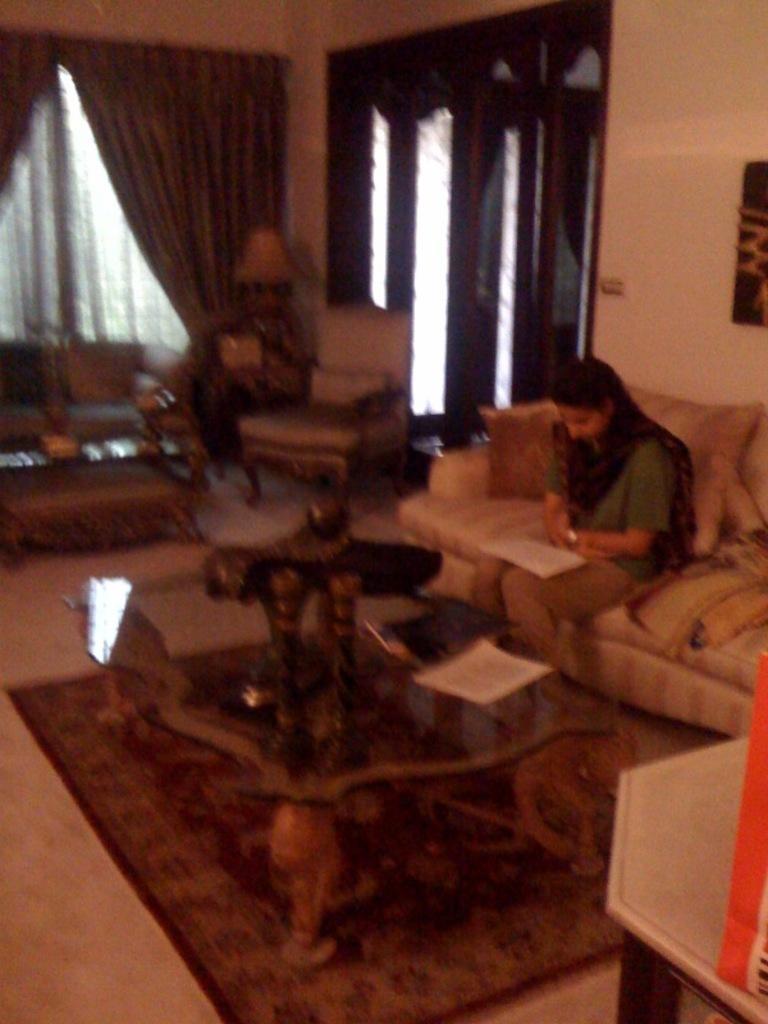Could you give a brief overview of what you see in this image? In the image there is a room with the furnished sofas, tables, frames, curtains and etc. In the bottom there is a mat covering the floor. There is a woman sitting on a sofa and reading a book. In the right there is an another table and a bag on it. In the center there is a window and a chair in front of that window. 